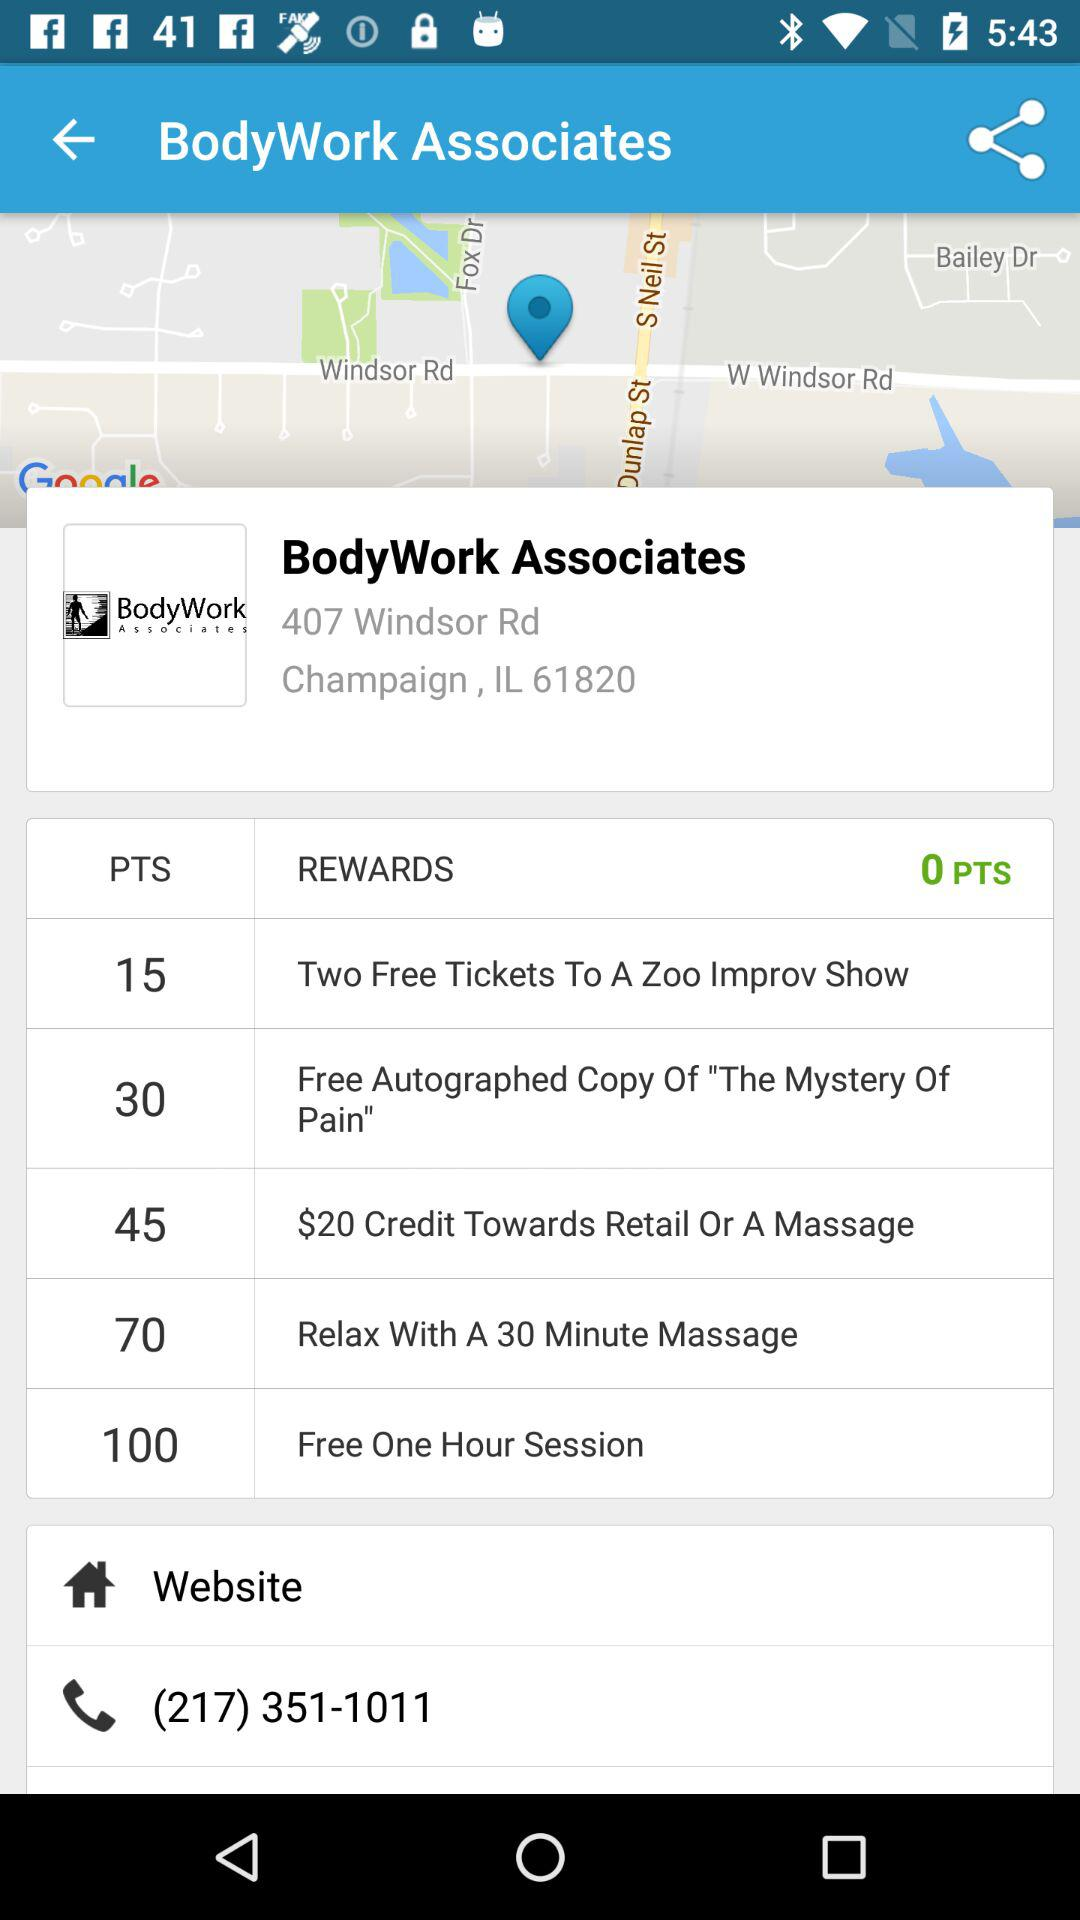How many $ can be credited towards retail? There can be $20 credited toward retail. 